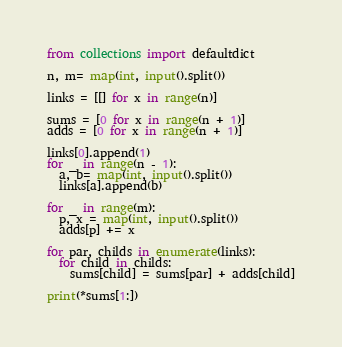<code> <loc_0><loc_0><loc_500><loc_500><_Python_>from collections import defaultdict

n, m= map(int, input().split())

links = [[] for x in range(n)]

sums = [0 for x in range(n + 1)]
adds = [0 for x in range(n + 1)]

links[0].append(1)
for _ in range(n - 1):
  a, b= map(int, input().split())
  links[a].append(b)

for _ in range(m):
  p, x = map(int, input().split())
  adds[p] += x

for par, childs in enumerate(links):
  for child in childs:
    sums[child] = sums[par] + adds[child]
  
print(*sums[1:])</code> 